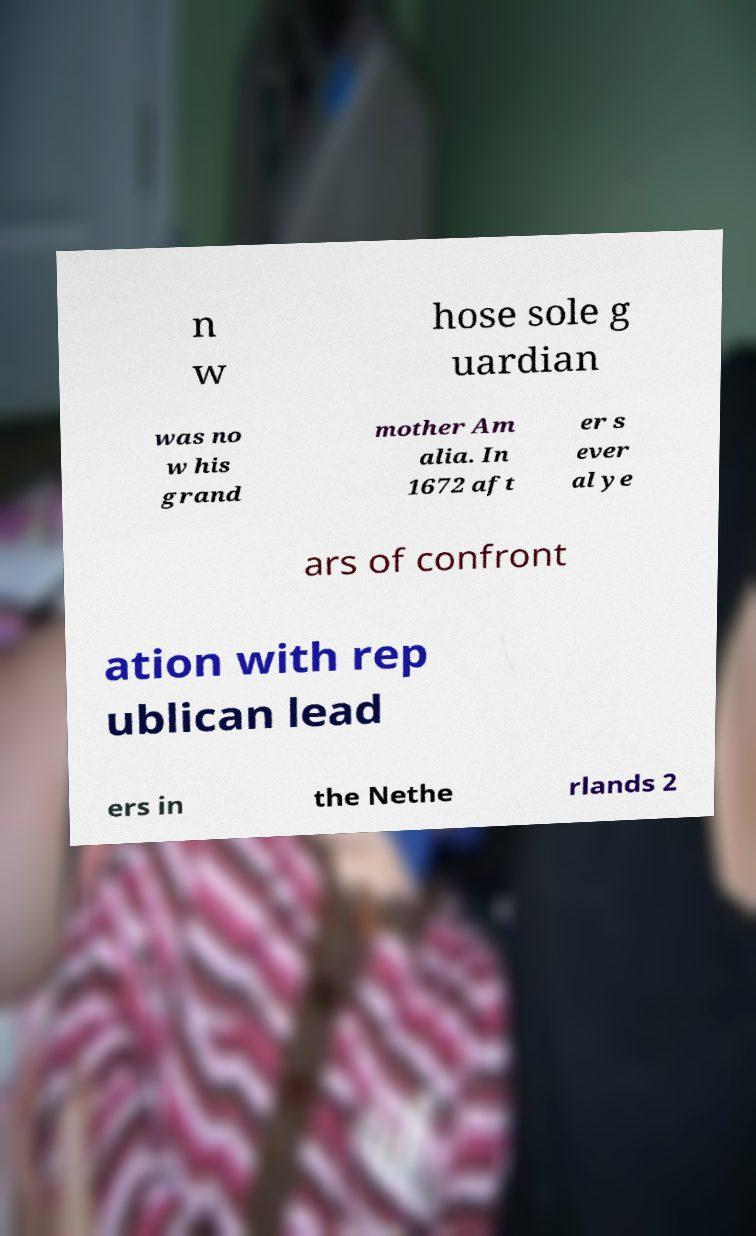There's text embedded in this image that I need extracted. Can you transcribe it verbatim? n w hose sole g uardian was no w his grand mother Am alia. In 1672 aft er s ever al ye ars of confront ation with rep ublican lead ers in the Nethe rlands 2 